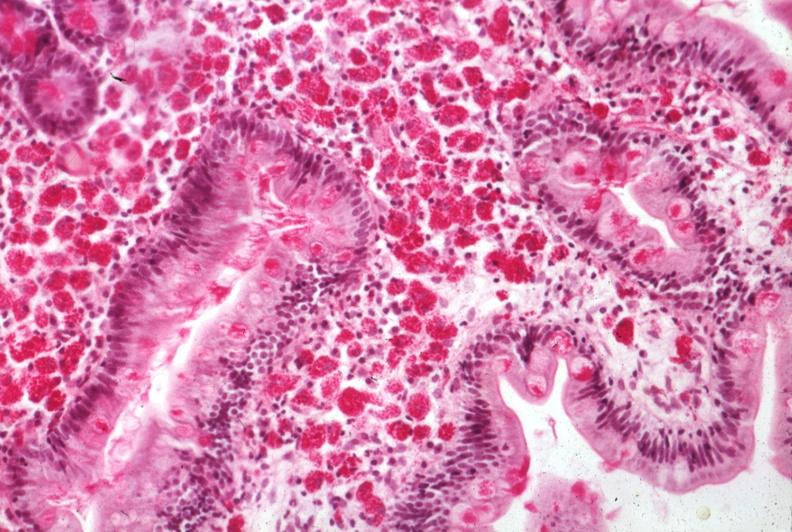what does this image show?
Answer the question using a single word or phrase. Med pas hematoxylin section of mucosa excellent example source 